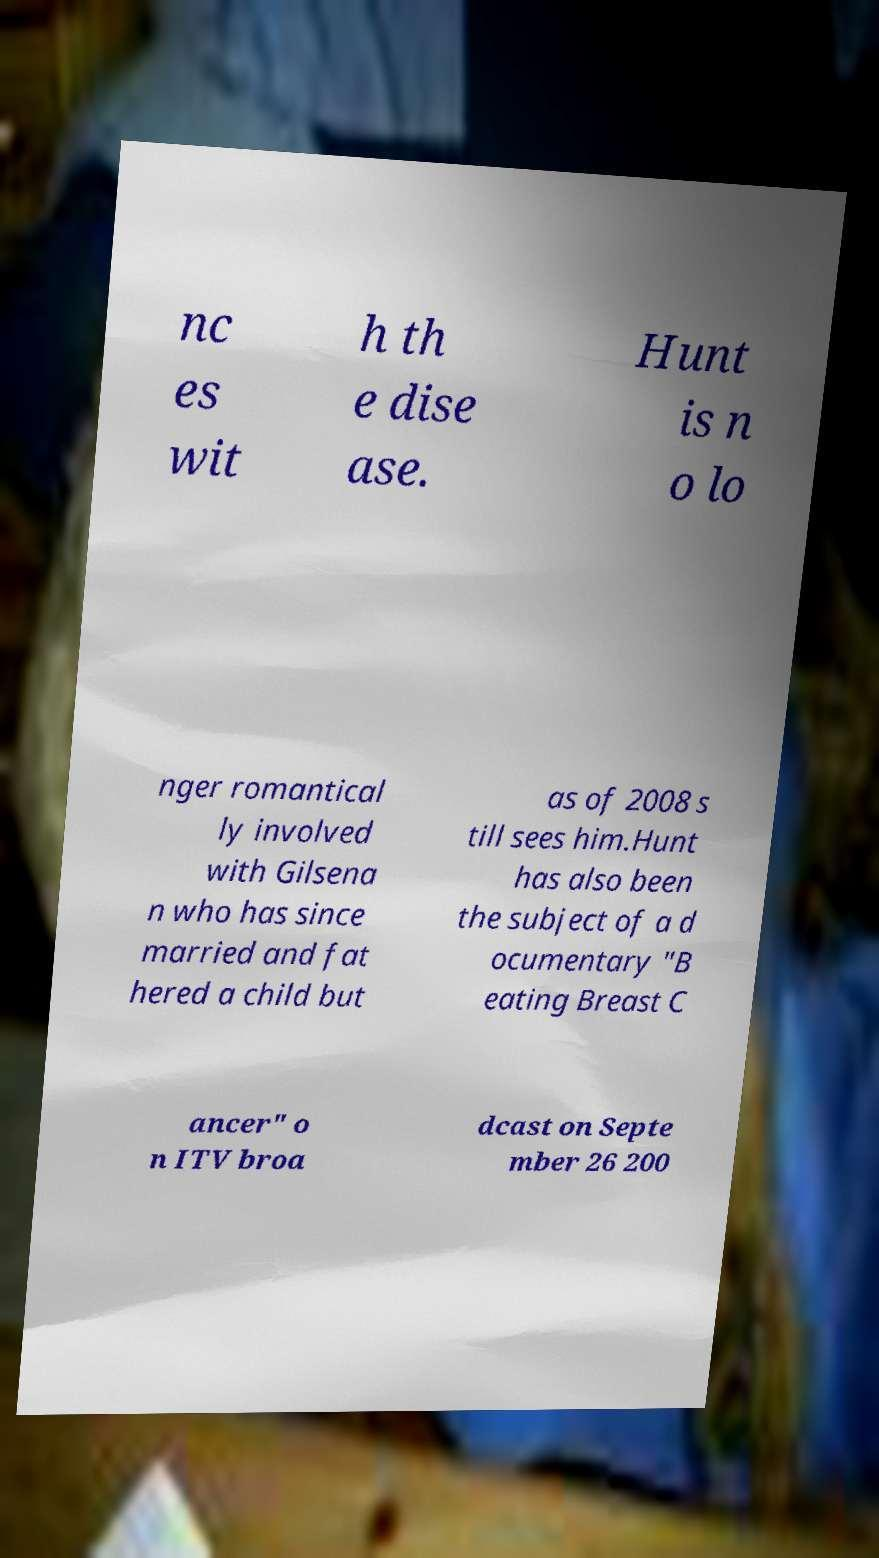Please read and relay the text visible in this image. What does it say? nc es wit h th e dise ase. Hunt is n o lo nger romantical ly involved with Gilsena n who has since married and fat hered a child but as of 2008 s till sees him.Hunt has also been the subject of a d ocumentary "B eating Breast C ancer" o n ITV broa dcast on Septe mber 26 200 